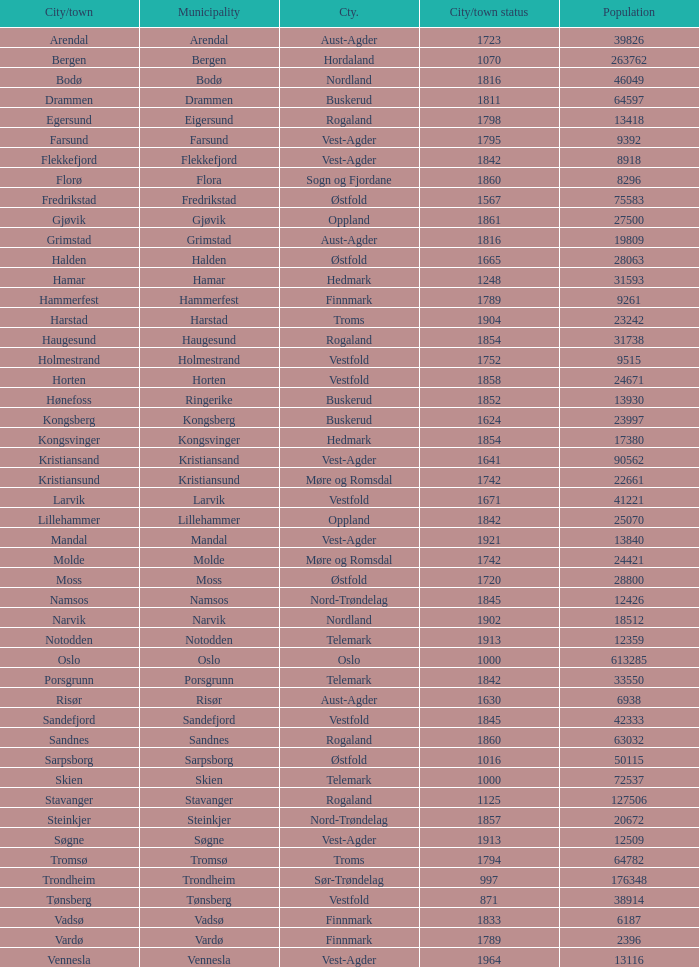What are the cities/towns located in the municipality of Moss? Moss. Could you parse the entire table? {'header': ['City/town', 'Municipality', 'Cty.', 'City/town status', 'Population'], 'rows': [['Arendal', 'Arendal', 'Aust-Agder', '1723', '39826'], ['Bergen', 'Bergen', 'Hordaland', '1070', '263762'], ['Bodø', 'Bodø', 'Nordland', '1816', '46049'], ['Drammen', 'Drammen', 'Buskerud', '1811', '64597'], ['Egersund', 'Eigersund', 'Rogaland', '1798', '13418'], ['Farsund', 'Farsund', 'Vest-Agder', '1795', '9392'], ['Flekkefjord', 'Flekkefjord', 'Vest-Agder', '1842', '8918'], ['Florø', 'Flora', 'Sogn og Fjordane', '1860', '8296'], ['Fredrikstad', 'Fredrikstad', 'Østfold', '1567', '75583'], ['Gjøvik', 'Gjøvik', 'Oppland', '1861', '27500'], ['Grimstad', 'Grimstad', 'Aust-Agder', '1816', '19809'], ['Halden', 'Halden', 'Østfold', '1665', '28063'], ['Hamar', 'Hamar', 'Hedmark', '1248', '31593'], ['Hammerfest', 'Hammerfest', 'Finnmark', '1789', '9261'], ['Harstad', 'Harstad', 'Troms', '1904', '23242'], ['Haugesund', 'Haugesund', 'Rogaland', '1854', '31738'], ['Holmestrand', 'Holmestrand', 'Vestfold', '1752', '9515'], ['Horten', 'Horten', 'Vestfold', '1858', '24671'], ['Hønefoss', 'Ringerike', 'Buskerud', '1852', '13930'], ['Kongsberg', 'Kongsberg', 'Buskerud', '1624', '23997'], ['Kongsvinger', 'Kongsvinger', 'Hedmark', '1854', '17380'], ['Kristiansand', 'Kristiansand', 'Vest-Agder', '1641', '90562'], ['Kristiansund', 'Kristiansund', 'Møre og Romsdal', '1742', '22661'], ['Larvik', 'Larvik', 'Vestfold', '1671', '41221'], ['Lillehammer', 'Lillehammer', 'Oppland', '1842', '25070'], ['Mandal', 'Mandal', 'Vest-Agder', '1921', '13840'], ['Molde', 'Molde', 'Møre og Romsdal', '1742', '24421'], ['Moss', 'Moss', 'Østfold', '1720', '28800'], ['Namsos', 'Namsos', 'Nord-Trøndelag', '1845', '12426'], ['Narvik', 'Narvik', 'Nordland', '1902', '18512'], ['Notodden', 'Notodden', 'Telemark', '1913', '12359'], ['Oslo', 'Oslo', 'Oslo', '1000', '613285'], ['Porsgrunn', 'Porsgrunn', 'Telemark', '1842', '33550'], ['Risør', 'Risør', 'Aust-Agder', '1630', '6938'], ['Sandefjord', 'Sandefjord', 'Vestfold', '1845', '42333'], ['Sandnes', 'Sandnes', 'Rogaland', '1860', '63032'], ['Sarpsborg', 'Sarpsborg', 'Østfold', '1016', '50115'], ['Skien', 'Skien', 'Telemark', '1000', '72537'], ['Stavanger', 'Stavanger', 'Rogaland', '1125', '127506'], ['Steinkjer', 'Steinkjer', 'Nord-Trøndelag', '1857', '20672'], ['Søgne', 'Søgne', 'Vest-Agder', '1913', '12509'], ['Tromsø', 'Tromsø', 'Troms', '1794', '64782'], ['Trondheim', 'Trondheim', 'Sør-Trøndelag', '997', '176348'], ['Tønsberg', 'Tønsberg', 'Vestfold', '871', '38914'], ['Vadsø', 'Vadsø', 'Finnmark', '1833', '6187'], ['Vardø', 'Vardø', 'Finnmark', '1789', '2396'], ['Vennesla', 'Vennesla', 'Vest-Agder', '1964', '13116']]} 